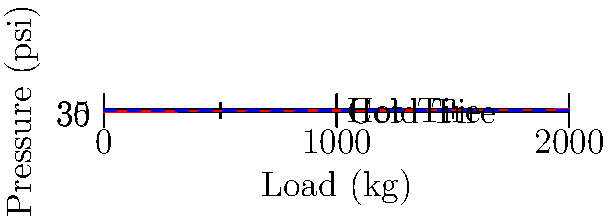As a cabdriver, you know that tire pressure is crucial for safety and fuel efficiency. The graph shows how tire pressure changes with load for both cold and hot tires. If your cab's tires are inflated to 33 psi when cold, what would be the approximate pressure (in psi) when the tires heat up during a long fare with a full load of passengers and luggage (about 1500 kg)? To solve this problem, we'll follow these steps:

1. Understand the graph:
   - The x-axis represents the load in kg
   - The y-axis represents the tire pressure in psi
   - The lower dashed line represents cold tire pressure
   - The upper dashed line represents hot tire pressure

2. Locate the relevant points:
   - We start at 33 psi for cold tires (lower dashed line)
   - We need to find the pressure for a 1500 kg load with hot tires

3. Find the difference between hot and cold tire pressures:
   - The gap between the two dashed lines is 3 psi (36 - 33)

4. Determine the hot tire pressure:
   - Start with the cold tire pressure: 33 psi
   - Add the difference due to heating: 3 psi
   - Hot tire pressure = 33 psi + 3 psi = 36 psi

5. Verify on the graph:
   - At 1500 kg load, the hot tire line (upper dashed) is indeed at 36 psi

Therefore, when the tires heat up during a long fare with a full load, the pressure would increase to approximately 36 psi.
Answer: 36 psi 